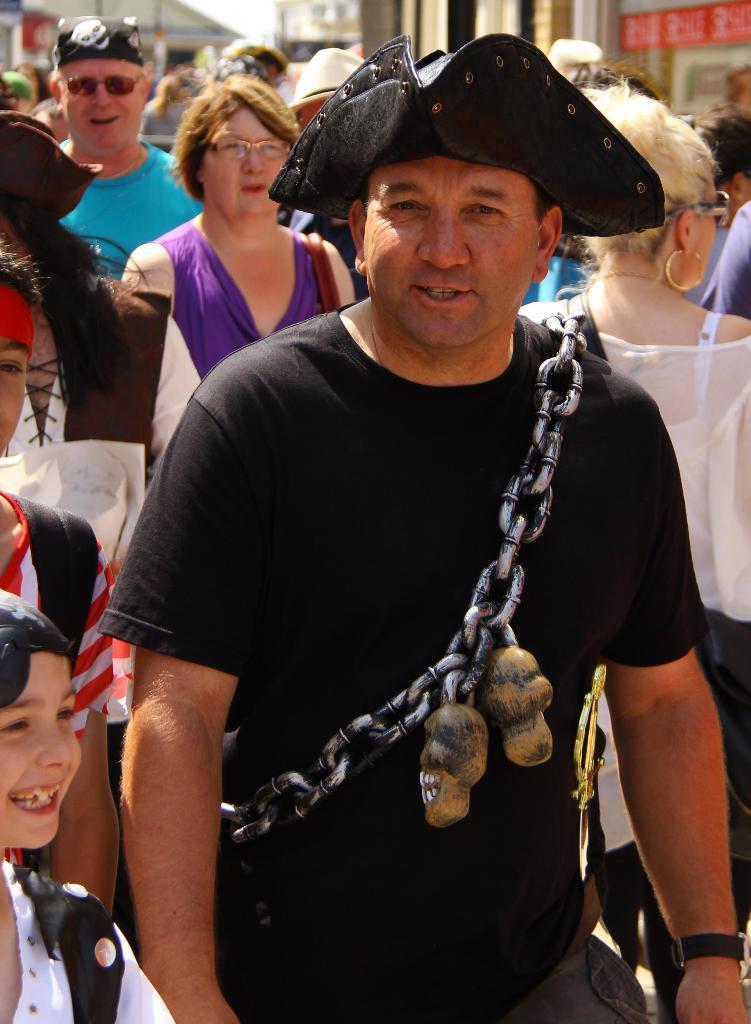In one or two sentences, can you explain what this image depicts? In this image there are a group of persons, there is a man wearing a hat, there is a man wearing a metal chain, at the background of the image there are buildings. 